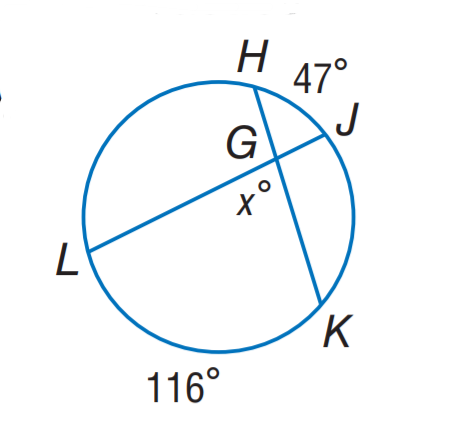Answer the mathemtical geometry problem and directly provide the correct option letter.
Question: Find x.
Choices: A: 47 B: 58 C: 81.5 D: 94 C 